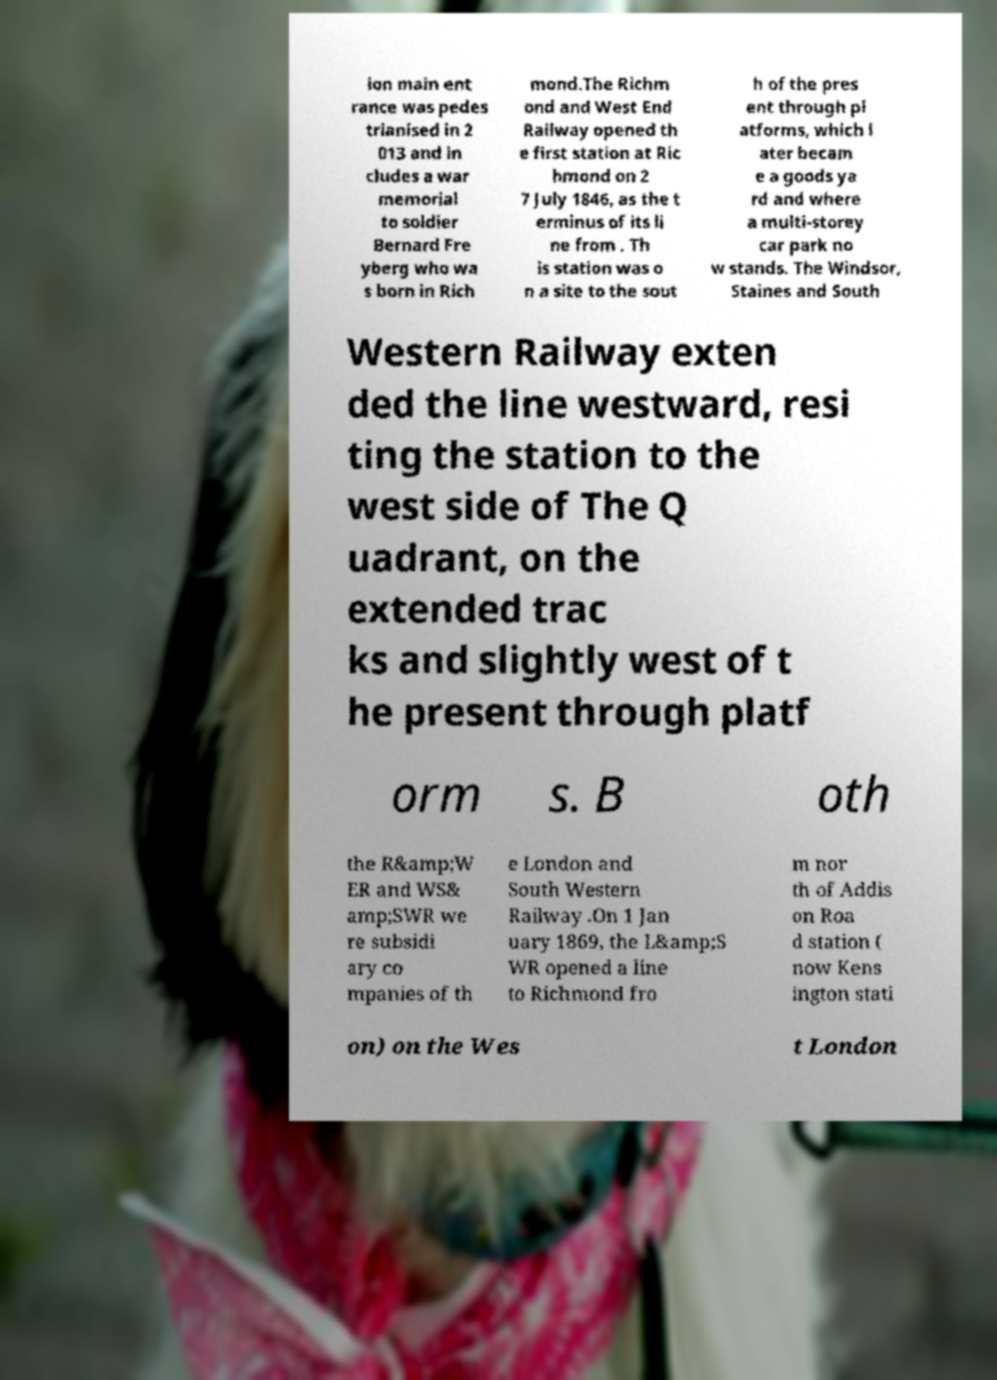Please read and relay the text visible in this image. What does it say? ion main ent rance was pedes trianised in 2 013 and in cludes a war memorial to soldier Bernard Fre yberg who wa s born in Rich mond.The Richm ond and West End Railway opened th e first station at Ric hmond on 2 7 July 1846, as the t erminus of its li ne from . Th is station was o n a site to the sout h of the pres ent through pl atforms, which l ater becam e a goods ya rd and where a multi-storey car park no w stands. The Windsor, Staines and South Western Railway exten ded the line westward, resi ting the station to the west side of The Q uadrant, on the extended trac ks and slightly west of t he present through platf orm s. B oth the R&amp;W ER and WS& amp;SWR we re subsidi ary co mpanies of th e London and South Western Railway .On 1 Jan uary 1869, the L&amp;S WR opened a line to Richmond fro m nor th of Addis on Roa d station ( now Kens ington stati on) on the Wes t London 